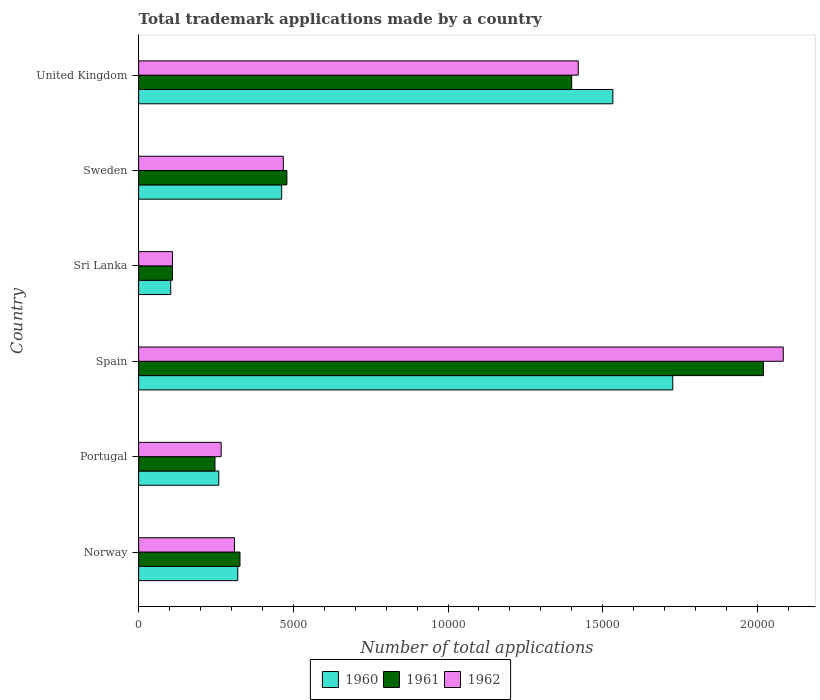Are the number of bars on each tick of the Y-axis equal?
Provide a succinct answer. Yes. How many bars are there on the 1st tick from the top?
Ensure brevity in your answer.  3. How many bars are there on the 5th tick from the bottom?
Ensure brevity in your answer.  3. In how many cases, is the number of bars for a given country not equal to the number of legend labels?
Give a very brief answer. 0. What is the number of applications made by in 1960 in United Kingdom?
Provide a succinct answer. 1.53e+04. Across all countries, what is the maximum number of applications made by in 1962?
Make the answer very short. 2.08e+04. Across all countries, what is the minimum number of applications made by in 1961?
Offer a very short reply. 1092. In which country was the number of applications made by in 1962 minimum?
Your answer should be compact. Sri Lanka. What is the total number of applications made by in 1961 in the graph?
Offer a terse response. 4.58e+04. What is the difference between the number of applications made by in 1961 in Norway and that in Sweden?
Your response must be concise. -1516. What is the difference between the number of applications made by in 1962 in United Kingdom and the number of applications made by in 1960 in Sweden?
Make the answer very short. 9586. What is the average number of applications made by in 1961 per country?
Provide a short and direct response. 7636.5. What is the difference between the number of applications made by in 1962 and number of applications made by in 1960 in United Kingdom?
Make the answer very short. -1118. In how many countries, is the number of applications made by in 1962 greater than 14000 ?
Provide a succinct answer. 2. What is the ratio of the number of applications made by in 1961 in Portugal to that in Spain?
Provide a succinct answer. 0.12. Is the difference between the number of applications made by in 1962 in Portugal and Sweden greater than the difference between the number of applications made by in 1960 in Portugal and Sweden?
Give a very brief answer. Yes. What is the difference between the highest and the second highest number of applications made by in 1962?
Offer a terse response. 6625. What is the difference between the highest and the lowest number of applications made by in 1961?
Keep it short and to the point. 1.91e+04. Is the sum of the number of applications made by in 1960 in Norway and Portugal greater than the maximum number of applications made by in 1961 across all countries?
Make the answer very short. No. What does the 3rd bar from the bottom in Portugal represents?
Provide a succinct answer. 1962. Is it the case that in every country, the sum of the number of applications made by in 1962 and number of applications made by in 1961 is greater than the number of applications made by in 1960?
Your answer should be very brief. Yes. What is the difference between two consecutive major ticks on the X-axis?
Your response must be concise. 5000. Does the graph contain grids?
Keep it short and to the point. No. Where does the legend appear in the graph?
Give a very brief answer. Bottom center. How many legend labels are there?
Your answer should be very brief. 3. How are the legend labels stacked?
Your answer should be compact. Horizontal. What is the title of the graph?
Your answer should be very brief. Total trademark applications made by a country. Does "1991" appear as one of the legend labels in the graph?
Give a very brief answer. No. What is the label or title of the X-axis?
Make the answer very short. Number of total applications. What is the Number of total applications in 1960 in Norway?
Offer a very short reply. 3204. What is the Number of total applications in 1961 in Norway?
Provide a short and direct response. 3276. What is the Number of total applications in 1962 in Norway?
Offer a very short reply. 3098. What is the Number of total applications of 1960 in Portugal?
Your response must be concise. 2590. What is the Number of total applications of 1961 in Portugal?
Make the answer very short. 2468. What is the Number of total applications in 1962 in Portugal?
Your answer should be compact. 2668. What is the Number of total applications of 1960 in Spain?
Offer a very short reply. 1.73e+04. What is the Number of total applications of 1961 in Spain?
Offer a very short reply. 2.02e+04. What is the Number of total applications of 1962 in Spain?
Offer a terse response. 2.08e+04. What is the Number of total applications of 1960 in Sri Lanka?
Give a very brief answer. 1037. What is the Number of total applications of 1961 in Sri Lanka?
Ensure brevity in your answer.  1092. What is the Number of total applications of 1962 in Sri Lanka?
Provide a short and direct response. 1095. What is the Number of total applications of 1960 in Sweden?
Provide a succinct answer. 4624. What is the Number of total applications in 1961 in Sweden?
Your response must be concise. 4792. What is the Number of total applications of 1962 in Sweden?
Your answer should be compact. 4677. What is the Number of total applications in 1960 in United Kingdom?
Provide a short and direct response. 1.53e+04. What is the Number of total applications in 1961 in United Kingdom?
Make the answer very short. 1.40e+04. What is the Number of total applications in 1962 in United Kingdom?
Provide a short and direct response. 1.42e+04. Across all countries, what is the maximum Number of total applications of 1960?
Your answer should be compact. 1.73e+04. Across all countries, what is the maximum Number of total applications in 1961?
Provide a short and direct response. 2.02e+04. Across all countries, what is the maximum Number of total applications in 1962?
Ensure brevity in your answer.  2.08e+04. Across all countries, what is the minimum Number of total applications of 1960?
Offer a very short reply. 1037. Across all countries, what is the minimum Number of total applications of 1961?
Offer a very short reply. 1092. Across all countries, what is the minimum Number of total applications of 1962?
Your answer should be very brief. 1095. What is the total Number of total applications of 1960 in the graph?
Offer a terse response. 4.40e+04. What is the total Number of total applications in 1961 in the graph?
Your answer should be compact. 4.58e+04. What is the total Number of total applications of 1962 in the graph?
Provide a short and direct response. 4.66e+04. What is the difference between the Number of total applications in 1960 in Norway and that in Portugal?
Make the answer very short. 614. What is the difference between the Number of total applications in 1961 in Norway and that in Portugal?
Provide a short and direct response. 808. What is the difference between the Number of total applications in 1962 in Norway and that in Portugal?
Provide a short and direct response. 430. What is the difference between the Number of total applications of 1960 in Norway and that in Spain?
Offer a very short reply. -1.41e+04. What is the difference between the Number of total applications in 1961 in Norway and that in Spain?
Your answer should be very brief. -1.69e+04. What is the difference between the Number of total applications of 1962 in Norway and that in Spain?
Provide a short and direct response. -1.77e+04. What is the difference between the Number of total applications in 1960 in Norway and that in Sri Lanka?
Keep it short and to the point. 2167. What is the difference between the Number of total applications of 1961 in Norway and that in Sri Lanka?
Your answer should be very brief. 2184. What is the difference between the Number of total applications of 1962 in Norway and that in Sri Lanka?
Your response must be concise. 2003. What is the difference between the Number of total applications of 1960 in Norway and that in Sweden?
Your response must be concise. -1420. What is the difference between the Number of total applications of 1961 in Norway and that in Sweden?
Ensure brevity in your answer.  -1516. What is the difference between the Number of total applications of 1962 in Norway and that in Sweden?
Make the answer very short. -1579. What is the difference between the Number of total applications of 1960 in Norway and that in United Kingdom?
Your response must be concise. -1.21e+04. What is the difference between the Number of total applications of 1961 in Norway and that in United Kingdom?
Give a very brief answer. -1.07e+04. What is the difference between the Number of total applications of 1962 in Norway and that in United Kingdom?
Provide a succinct answer. -1.11e+04. What is the difference between the Number of total applications of 1960 in Portugal and that in Spain?
Provide a short and direct response. -1.47e+04. What is the difference between the Number of total applications of 1961 in Portugal and that in Spain?
Offer a very short reply. -1.77e+04. What is the difference between the Number of total applications of 1962 in Portugal and that in Spain?
Ensure brevity in your answer.  -1.82e+04. What is the difference between the Number of total applications in 1960 in Portugal and that in Sri Lanka?
Offer a terse response. 1553. What is the difference between the Number of total applications in 1961 in Portugal and that in Sri Lanka?
Ensure brevity in your answer.  1376. What is the difference between the Number of total applications of 1962 in Portugal and that in Sri Lanka?
Offer a terse response. 1573. What is the difference between the Number of total applications of 1960 in Portugal and that in Sweden?
Keep it short and to the point. -2034. What is the difference between the Number of total applications in 1961 in Portugal and that in Sweden?
Provide a succinct answer. -2324. What is the difference between the Number of total applications of 1962 in Portugal and that in Sweden?
Your response must be concise. -2009. What is the difference between the Number of total applications of 1960 in Portugal and that in United Kingdom?
Offer a terse response. -1.27e+04. What is the difference between the Number of total applications of 1961 in Portugal and that in United Kingdom?
Give a very brief answer. -1.15e+04. What is the difference between the Number of total applications in 1962 in Portugal and that in United Kingdom?
Offer a terse response. -1.15e+04. What is the difference between the Number of total applications in 1960 in Spain and that in Sri Lanka?
Give a very brief answer. 1.62e+04. What is the difference between the Number of total applications of 1961 in Spain and that in Sri Lanka?
Make the answer very short. 1.91e+04. What is the difference between the Number of total applications in 1962 in Spain and that in Sri Lanka?
Your response must be concise. 1.97e+04. What is the difference between the Number of total applications in 1960 in Spain and that in Sweden?
Your response must be concise. 1.26e+04. What is the difference between the Number of total applications in 1961 in Spain and that in Sweden?
Offer a terse response. 1.54e+04. What is the difference between the Number of total applications in 1962 in Spain and that in Sweden?
Your response must be concise. 1.62e+04. What is the difference between the Number of total applications of 1960 in Spain and that in United Kingdom?
Offer a terse response. 1935. What is the difference between the Number of total applications in 1961 in Spain and that in United Kingdom?
Offer a very short reply. 6197. What is the difference between the Number of total applications in 1962 in Spain and that in United Kingdom?
Your response must be concise. 6625. What is the difference between the Number of total applications of 1960 in Sri Lanka and that in Sweden?
Offer a very short reply. -3587. What is the difference between the Number of total applications in 1961 in Sri Lanka and that in Sweden?
Make the answer very short. -3700. What is the difference between the Number of total applications of 1962 in Sri Lanka and that in Sweden?
Provide a succinct answer. -3582. What is the difference between the Number of total applications of 1960 in Sri Lanka and that in United Kingdom?
Your response must be concise. -1.43e+04. What is the difference between the Number of total applications of 1961 in Sri Lanka and that in United Kingdom?
Offer a terse response. -1.29e+04. What is the difference between the Number of total applications in 1962 in Sri Lanka and that in United Kingdom?
Make the answer very short. -1.31e+04. What is the difference between the Number of total applications in 1960 in Sweden and that in United Kingdom?
Provide a short and direct response. -1.07e+04. What is the difference between the Number of total applications in 1961 in Sweden and that in United Kingdom?
Provide a short and direct response. -9205. What is the difference between the Number of total applications in 1962 in Sweden and that in United Kingdom?
Your answer should be very brief. -9533. What is the difference between the Number of total applications in 1960 in Norway and the Number of total applications in 1961 in Portugal?
Provide a succinct answer. 736. What is the difference between the Number of total applications in 1960 in Norway and the Number of total applications in 1962 in Portugal?
Offer a very short reply. 536. What is the difference between the Number of total applications of 1961 in Norway and the Number of total applications of 1962 in Portugal?
Provide a short and direct response. 608. What is the difference between the Number of total applications of 1960 in Norway and the Number of total applications of 1961 in Spain?
Offer a terse response. -1.70e+04. What is the difference between the Number of total applications in 1960 in Norway and the Number of total applications in 1962 in Spain?
Your answer should be very brief. -1.76e+04. What is the difference between the Number of total applications of 1961 in Norway and the Number of total applications of 1962 in Spain?
Offer a terse response. -1.76e+04. What is the difference between the Number of total applications in 1960 in Norway and the Number of total applications in 1961 in Sri Lanka?
Your answer should be very brief. 2112. What is the difference between the Number of total applications of 1960 in Norway and the Number of total applications of 1962 in Sri Lanka?
Ensure brevity in your answer.  2109. What is the difference between the Number of total applications of 1961 in Norway and the Number of total applications of 1962 in Sri Lanka?
Provide a succinct answer. 2181. What is the difference between the Number of total applications of 1960 in Norway and the Number of total applications of 1961 in Sweden?
Give a very brief answer. -1588. What is the difference between the Number of total applications of 1960 in Norway and the Number of total applications of 1962 in Sweden?
Your response must be concise. -1473. What is the difference between the Number of total applications in 1961 in Norway and the Number of total applications in 1962 in Sweden?
Provide a succinct answer. -1401. What is the difference between the Number of total applications in 1960 in Norway and the Number of total applications in 1961 in United Kingdom?
Make the answer very short. -1.08e+04. What is the difference between the Number of total applications of 1960 in Norway and the Number of total applications of 1962 in United Kingdom?
Ensure brevity in your answer.  -1.10e+04. What is the difference between the Number of total applications of 1961 in Norway and the Number of total applications of 1962 in United Kingdom?
Keep it short and to the point. -1.09e+04. What is the difference between the Number of total applications of 1960 in Portugal and the Number of total applications of 1961 in Spain?
Offer a terse response. -1.76e+04. What is the difference between the Number of total applications of 1960 in Portugal and the Number of total applications of 1962 in Spain?
Provide a succinct answer. -1.82e+04. What is the difference between the Number of total applications in 1961 in Portugal and the Number of total applications in 1962 in Spain?
Keep it short and to the point. -1.84e+04. What is the difference between the Number of total applications in 1960 in Portugal and the Number of total applications in 1961 in Sri Lanka?
Keep it short and to the point. 1498. What is the difference between the Number of total applications of 1960 in Portugal and the Number of total applications of 1962 in Sri Lanka?
Offer a very short reply. 1495. What is the difference between the Number of total applications of 1961 in Portugal and the Number of total applications of 1962 in Sri Lanka?
Your answer should be very brief. 1373. What is the difference between the Number of total applications in 1960 in Portugal and the Number of total applications in 1961 in Sweden?
Ensure brevity in your answer.  -2202. What is the difference between the Number of total applications in 1960 in Portugal and the Number of total applications in 1962 in Sweden?
Ensure brevity in your answer.  -2087. What is the difference between the Number of total applications of 1961 in Portugal and the Number of total applications of 1962 in Sweden?
Offer a very short reply. -2209. What is the difference between the Number of total applications in 1960 in Portugal and the Number of total applications in 1961 in United Kingdom?
Your response must be concise. -1.14e+04. What is the difference between the Number of total applications of 1960 in Portugal and the Number of total applications of 1962 in United Kingdom?
Give a very brief answer. -1.16e+04. What is the difference between the Number of total applications of 1961 in Portugal and the Number of total applications of 1962 in United Kingdom?
Offer a very short reply. -1.17e+04. What is the difference between the Number of total applications in 1960 in Spain and the Number of total applications in 1961 in Sri Lanka?
Provide a succinct answer. 1.62e+04. What is the difference between the Number of total applications of 1960 in Spain and the Number of total applications of 1962 in Sri Lanka?
Offer a very short reply. 1.62e+04. What is the difference between the Number of total applications of 1961 in Spain and the Number of total applications of 1962 in Sri Lanka?
Provide a succinct answer. 1.91e+04. What is the difference between the Number of total applications of 1960 in Spain and the Number of total applications of 1961 in Sweden?
Provide a short and direct response. 1.25e+04. What is the difference between the Number of total applications in 1960 in Spain and the Number of total applications in 1962 in Sweden?
Your response must be concise. 1.26e+04. What is the difference between the Number of total applications of 1961 in Spain and the Number of total applications of 1962 in Sweden?
Give a very brief answer. 1.55e+04. What is the difference between the Number of total applications of 1960 in Spain and the Number of total applications of 1961 in United Kingdom?
Provide a succinct answer. 3266. What is the difference between the Number of total applications of 1960 in Spain and the Number of total applications of 1962 in United Kingdom?
Your answer should be compact. 3053. What is the difference between the Number of total applications of 1961 in Spain and the Number of total applications of 1962 in United Kingdom?
Keep it short and to the point. 5984. What is the difference between the Number of total applications in 1960 in Sri Lanka and the Number of total applications in 1961 in Sweden?
Provide a succinct answer. -3755. What is the difference between the Number of total applications of 1960 in Sri Lanka and the Number of total applications of 1962 in Sweden?
Your answer should be very brief. -3640. What is the difference between the Number of total applications of 1961 in Sri Lanka and the Number of total applications of 1962 in Sweden?
Your answer should be very brief. -3585. What is the difference between the Number of total applications in 1960 in Sri Lanka and the Number of total applications in 1961 in United Kingdom?
Keep it short and to the point. -1.30e+04. What is the difference between the Number of total applications in 1960 in Sri Lanka and the Number of total applications in 1962 in United Kingdom?
Your answer should be compact. -1.32e+04. What is the difference between the Number of total applications in 1961 in Sri Lanka and the Number of total applications in 1962 in United Kingdom?
Ensure brevity in your answer.  -1.31e+04. What is the difference between the Number of total applications of 1960 in Sweden and the Number of total applications of 1961 in United Kingdom?
Ensure brevity in your answer.  -9373. What is the difference between the Number of total applications of 1960 in Sweden and the Number of total applications of 1962 in United Kingdom?
Offer a very short reply. -9586. What is the difference between the Number of total applications in 1961 in Sweden and the Number of total applications in 1962 in United Kingdom?
Keep it short and to the point. -9418. What is the average Number of total applications in 1960 per country?
Ensure brevity in your answer.  7341. What is the average Number of total applications in 1961 per country?
Provide a succinct answer. 7636.5. What is the average Number of total applications in 1962 per country?
Your answer should be compact. 7763.83. What is the difference between the Number of total applications of 1960 and Number of total applications of 1961 in Norway?
Keep it short and to the point. -72. What is the difference between the Number of total applications of 1960 and Number of total applications of 1962 in Norway?
Your answer should be very brief. 106. What is the difference between the Number of total applications in 1961 and Number of total applications in 1962 in Norway?
Give a very brief answer. 178. What is the difference between the Number of total applications in 1960 and Number of total applications in 1961 in Portugal?
Keep it short and to the point. 122. What is the difference between the Number of total applications of 1960 and Number of total applications of 1962 in Portugal?
Provide a succinct answer. -78. What is the difference between the Number of total applications in 1961 and Number of total applications in 1962 in Portugal?
Provide a succinct answer. -200. What is the difference between the Number of total applications of 1960 and Number of total applications of 1961 in Spain?
Ensure brevity in your answer.  -2931. What is the difference between the Number of total applications in 1960 and Number of total applications in 1962 in Spain?
Ensure brevity in your answer.  -3572. What is the difference between the Number of total applications of 1961 and Number of total applications of 1962 in Spain?
Provide a short and direct response. -641. What is the difference between the Number of total applications of 1960 and Number of total applications of 1961 in Sri Lanka?
Provide a short and direct response. -55. What is the difference between the Number of total applications in 1960 and Number of total applications in 1962 in Sri Lanka?
Offer a very short reply. -58. What is the difference between the Number of total applications in 1961 and Number of total applications in 1962 in Sri Lanka?
Offer a terse response. -3. What is the difference between the Number of total applications in 1960 and Number of total applications in 1961 in Sweden?
Your answer should be very brief. -168. What is the difference between the Number of total applications in 1960 and Number of total applications in 1962 in Sweden?
Ensure brevity in your answer.  -53. What is the difference between the Number of total applications of 1961 and Number of total applications of 1962 in Sweden?
Your answer should be compact. 115. What is the difference between the Number of total applications of 1960 and Number of total applications of 1961 in United Kingdom?
Provide a short and direct response. 1331. What is the difference between the Number of total applications of 1960 and Number of total applications of 1962 in United Kingdom?
Offer a very short reply. 1118. What is the difference between the Number of total applications of 1961 and Number of total applications of 1962 in United Kingdom?
Your response must be concise. -213. What is the ratio of the Number of total applications of 1960 in Norway to that in Portugal?
Keep it short and to the point. 1.24. What is the ratio of the Number of total applications of 1961 in Norway to that in Portugal?
Offer a terse response. 1.33. What is the ratio of the Number of total applications of 1962 in Norway to that in Portugal?
Offer a terse response. 1.16. What is the ratio of the Number of total applications of 1960 in Norway to that in Spain?
Offer a very short reply. 0.19. What is the ratio of the Number of total applications of 1961 in Norway to that in Spain?
Your response must be concise. 0.16. What is the ratio of the Number of total applications in 1962 in Norway to that in Spain?
Keep it short and to the point. 0.15. What is the ratio of the Number of total applications of 1960 in Norway to that in Sri Lanka?
Offer a terse response. 3.09. What is the ratio of the Number of total applications of 1961 in Norway to that in Sri Lanka?
Offer a terse response. 3. What is the ratio of the Number of total applications of 1962 in Norway to that in Sri Lanka?
Ensure brevity in your answer.  2.83. What is the ratio of the Number of total applications in 1960 in Norway to that in Sweden?
Your answer should be very brief. 0.69. What is the ratio of the Number of total applications of 1961 in Norway to that in Sweden?
Keep it short and to the point. 0.68. What is the ratio of the Number of total applications of 1962 in Norway to that in Sweden?
Provide a succinct answer. 0.66. What is the ratio of the Number of total applications in 1960 in Norway to that in United Kingdom?
Your response must be concise. 0.21. What is the ratio of the Number of total applications of 1961 in Norway to that in United Kingdom?
Offer a terse response. 0.23. What is the ratio of the Number of total applications of 1962 in Norway to that in United Kingdom?
Provide a succinct answer. 0.22. What is the ratio of the Number of total applications of 1961 in Portugal to that in Spain?
Your answer should be very brief. 0.12. What is the ratio of the Number of total applications of 1962 in Portugal to that in Spain?
Offer a very short reply. 0.13. What is the ratio of the Number of total applications in 1960 in Portugal to that in Sri Lanka?
Keep it short and to the point. 2.5. What is the ratio of the Number of total applications in 1961 in Portugal to that in Sri Lanka?
Provide a short and direct response. 2.26. What is the ratio of the Number of total applications of 1962 in Portugal to that in Sri Lanka?
Provide a succinct answer. 2.44. What is the ratio of the Number of total applications of 1960 in Portugal to that in Sweden?
Give a very brief answer. 0.56. What is the ratio of the Number of total applications in 1961 in Portugal to that in Sweden?
Keep it short and to the point. 0.52. What is the ratio of the Number of total applications in 1962 in Portugal to that in Sweden?
Offer a very short reply. 0.57. What is the ratio of the Number of total applications of 1960 in Portugal to that in United Kingdom?
Your answer should be very brief. 0.17. What is the ratio of the Number of total applications in 1961 in Portugal to that in United Kingdom?
Your answer should be compact. 0.18. What is the ratio of the Number of total applications of 1962 in Portugal to that in United Kingdom?
Keep it short and to the point. 0.19. What is the ratio of the Number of total applications in 1960 in Spain to that in Sri Lanka?
Provide a succinct answer. 16.65. What is the ratio of the Number of total applications in 1961 in Spain to that in Sri Lanka?
Your answer should be very brief. 18.49. What is the ratio of the Number of total applications of 1962 in Spain to that in Sri Lanka?
Your answer should be very brief. 19.03. What is the ratio of the Number of total applications of 1960 in Spain to that in Sweden?
Provide a succinct answer. 3.73. What is the ratio of the Number of total applications in 1961 in Spain to that in Sweden?
Give a very brief answer. 4.21. What is the ratio of the Number of total applications of 1962 in Spain to that in Sweden?
Ensure brevity in your answer.  4.45. What is the ratio of the Number of total applications of 1960 in Spain to that in United Kingdom?
Keep it short and to the point. 1.13. What is the ratio of the Number of total applications in 1961 in Spain to that in United Kingdom?
Your answer should be very brief. 1.44. What is the ratio of the Number of total applications in 1962 in Spain to that in United Kingdom?
Offer a terse response. 1.47. What is the ratio of the Number of total applications of 1960 in Sri Lanka to that in Sweden?
Ensure brevity in your answer.  0.22. What is the ratio of the Number of total applications in 1961 in Sri Lanka to that in Sweden?
Your answer should be compact. 0.23. What is the ratio of the Number of total applications of 1962 in Sri Lanka to that in Sweden?
Your answer should be compact. 0.23. What is the ratio of the Number of total applications of 1960 in Sri Lanka to that in United Kingdom?
Offer a terse response. 0.07. What is the ratio of the Number of total applications of 1961 in Sri Lanka to that in United Kingdom?
Offer a very short reply. 0.08. What is the ratio of the Number of total applications in 1962 in Sri Lanka to that in United Kingdom?
Ensure brevity in your answer.  0.08. What is the ratio of the Number of total applications in 1960 in Sweden to that in United Kingdom?
Your answer should be compact. 0.3. What is the ratio of the Number of total applications of 1961 in Sweden to that in United Kingdom?
Ensure brevity in your answer.  0.34. What is the ratio of the Number of total applications in 1962 in Sweden to that in United Kingdom?
Your answer should be compact. 0.33. What is the difference between the highest and the second highest Number of total applications in 1960?
Ensure brevity in your answer.  1935. What is the difference between the highest and the second highest Number of total applications of 1961?
Provide a succinct answer. 6197. What is the difference between the highest and the second highest Number of total applications of 1962?
Keep it short and to the point. 6625. What is the difference between the highest and the lowest Number of total applications in 1960?
Offer a terse response. 1.62e+04. What is the difference between the highest and the lowest Number of total applications in 1961?
Your response must be concise. 1.91e+04. What is the difference between the highest and the lowest Number of total applications of 1962?
Offer a terse response. 1.97e+04. 